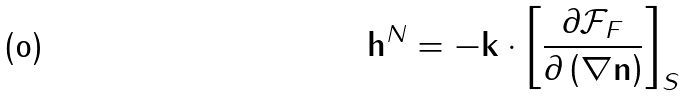Convert formula to latex. <formula><loc_0><loc_0><loc_500><loc_500>\mathbf h ^ { N } = - \mathbf k \cdot \left [ \frac { \partial \mathcal { F } _ { F } } { \partial \left ( \nabla \mathbf n \right ) } \right ] _ { S }</formula> 